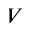Convert formula to latex. <formula><loc_0><loc_0><loc_500><loc_500>V</formula> 